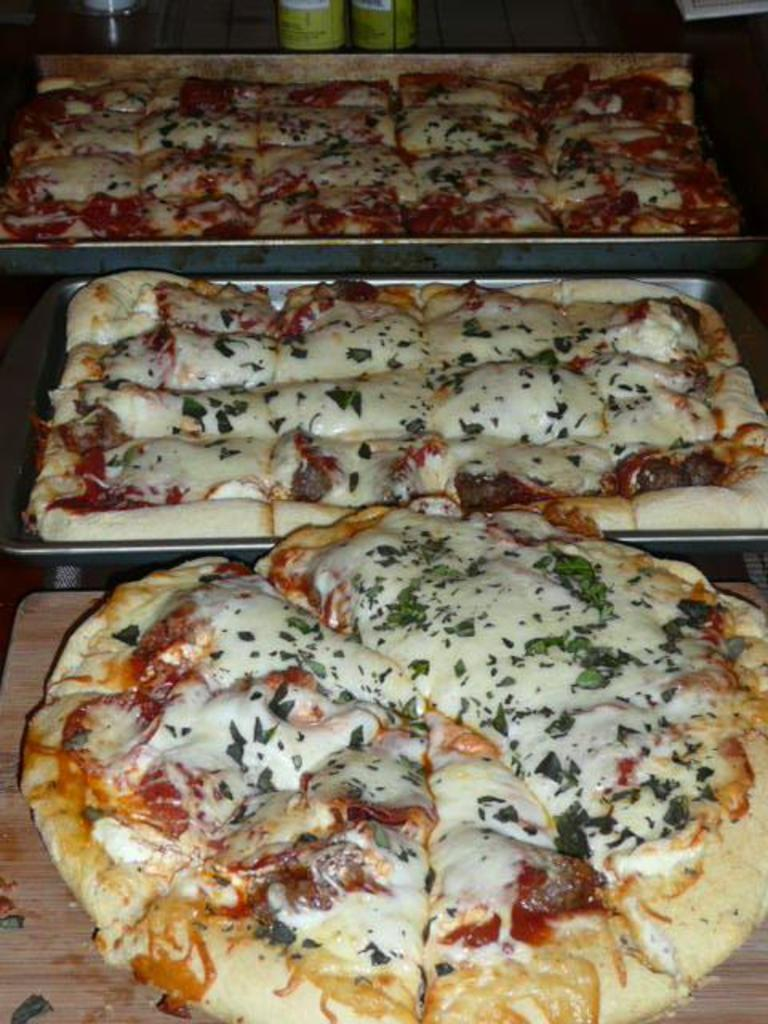What is present on the surface in the image? There is a chopping board in the image. What else can be seen on the surface? There are two trays in the image. What is inside the trays? There are pizzas in the trays. Are there any other items on the chopping board? There are two unspecified items on the chopping board. What type of ink can be seen on the pizzas in the image? There is no ink present on the pizzas in the image; they are simply pizzas in trays. 